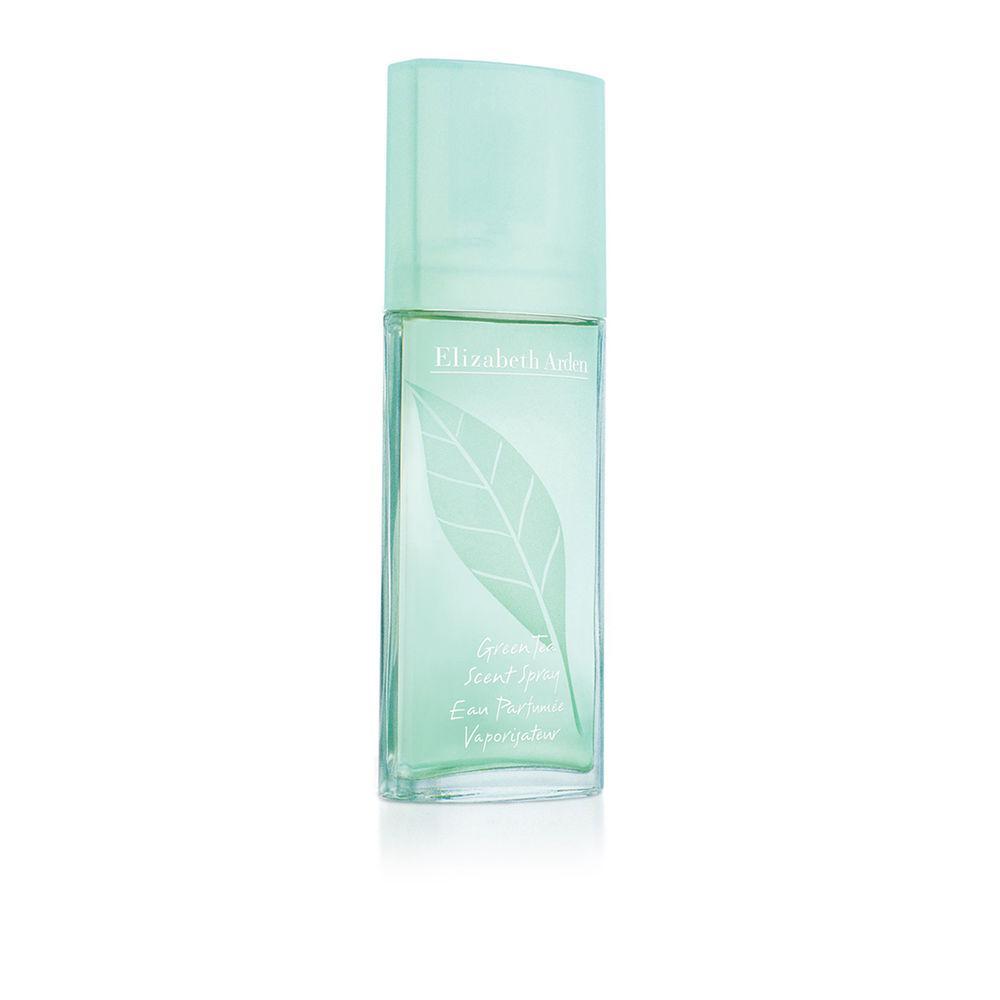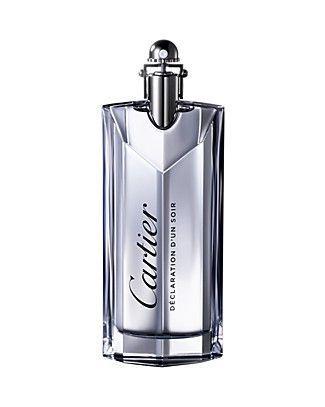The first image is the image on the left, the second image is the image on the right. For the images shown, is this caption "There are at most two bottles of perfume." true? Answer yes or no. Yes. The first image is the image on the left, the second image is the image on the right. For the images shown, is this caption "There are four perfume bottles in both images." true? Answer yes or no. No. 